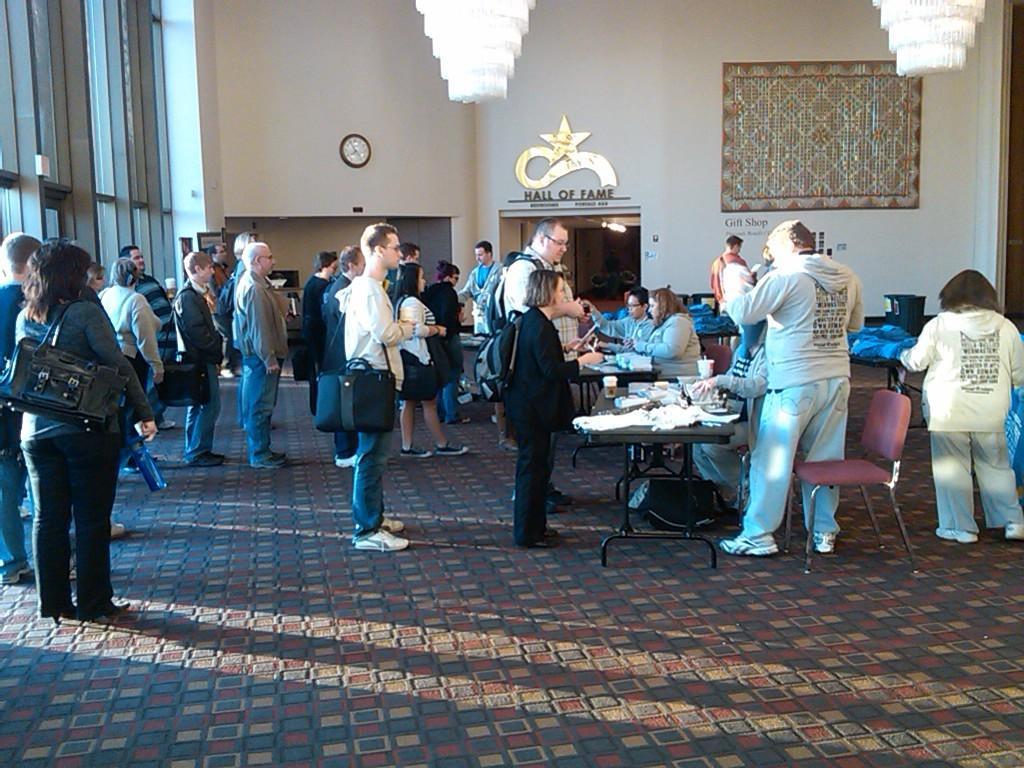Could you give a brief overview of what you see in this image? In this image I can see the group of people with different color dresses. I can see few people are wearing the bags. I can also see few people are siting in-front of the tables. On the tables I can see cups and many objects. In the background I can see the clock to the wall and there are chandelier lights in the top. 